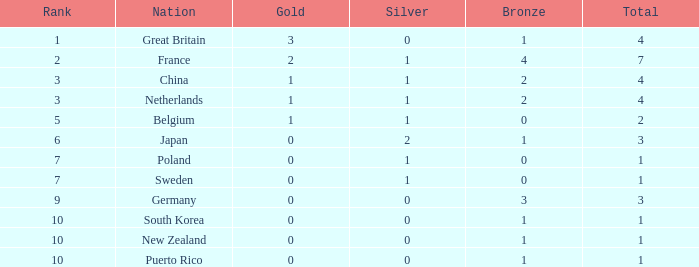What is the rank with 0 bronze? None. 